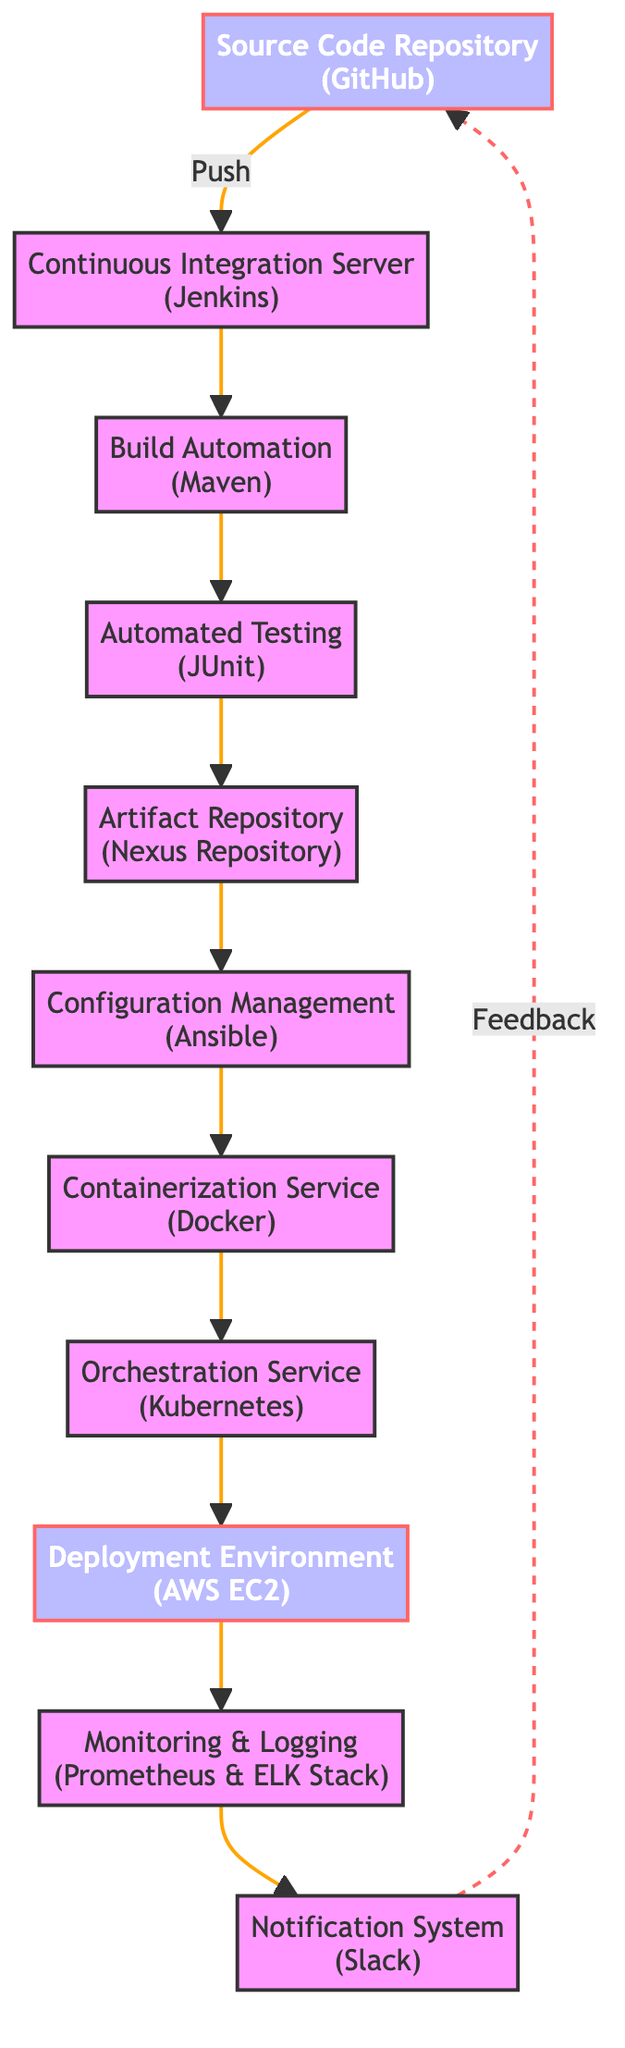What is the first node in the deployment pipeline? The first node is labeled "Source Code Repository" which indicates that this is where the codebase resides. It has a special designation with a distinct color in the flowchart.
Answer: Source Code Repository Which tool is associated with the "Containerization Service"? The diagram indicates that the "Containerization Service" node is associated with "Docker" as specified below its name.
Answer: Docker How many nodes are there in total in the diagram? By counting all the nodes listed in the flowchart, there are a total of 11 nodes. This includes all stages from the Source Code Repository to the Notification System.
Answer: 11 What is the relationship between "Automated Testing" and "Artifact Repository"? The relationship is direct; "Automated Testing" feeds into the "Artifact Repository". This means that after testing, the generated artifacts are stored in the repository.
Answer: Direct connection Which tool is used for monitoring and logging applications? The diagram states that "Prometheus & ELK Stack" is the tool associated with the "Monitoring & Logging" node, indicating these tools are used to track performance and logs.
Answer: Prometheus & ELK Stack What is the final stage before feedback is sent back to the source? The final stage before feedback is sent back to the "Source Code Repository" is "Notification System". Once processes are completed, notifications about success or failure are sent.
Answer: Notification System How many stages involve automation before deployment? There are three stages mentioned in the pipeline that involve automation before reaching the deployment phase: Continuous Integration Server, Build Automation, and Automated Testing. All three are critical automated processes in the deployment pipeline.
Answer: Three What type of service is "Kubernetes" classified as? In the context of the diagram, "Kubernetes" is classified as an "Orchestration Service", which means it automates the management of containerized applications.
Answer: Orchestration Service What triggers the Continuous Integration Server? The diagram indicates that the trigger for the "Continuous Integration Server" is a "Push" from the "Source Code Repository", implying a code change initiates this process.
Answer: Push 